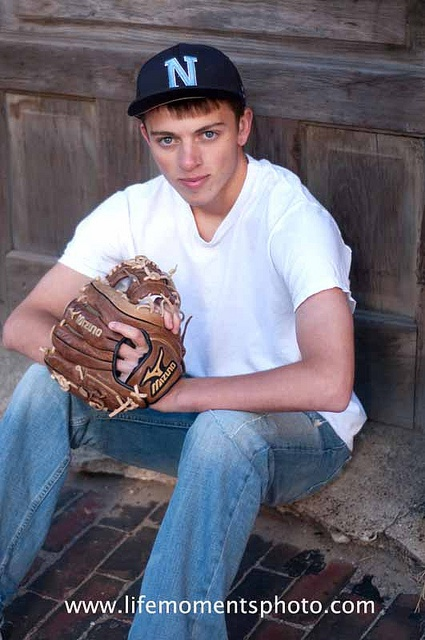Describe the objects in this image and their specific colors. I can see people in gray, lavender, and lightpink tones and baseball glove in gray, brown, maroon, and lightpink tones in this image. 